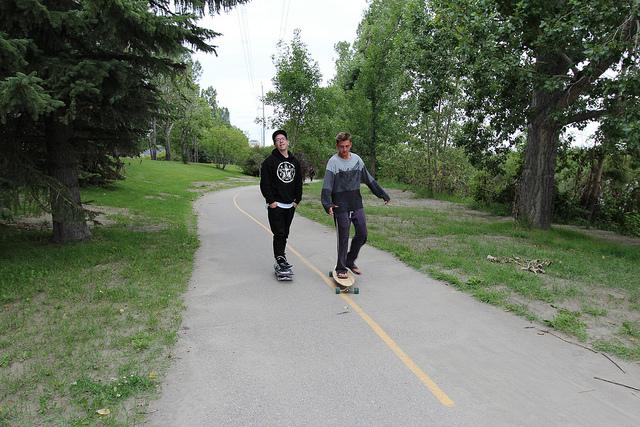How many potholes are visible?
Short answer required. 0. What is the man holding?
Concise answer only. Nothing. What is the pathway made of?
Write a very short answer. Cement. Is it dark out?
Quick response, please. No. Is the path crowded?
Answer briefly. No. Is this street covered in rain water?
Answer briefly. No. How many people are riding skateboards on this street?
Keep it brief. 2. What are the people doing?
Give a very brief answer. Skateboarding. What is he on?
Keep it brief. Skateboard. Are there cars in this picture?
Write a very short answer. No. What is cast?
Quick response, please. Nothing. What is the kids on?
Keep it brief. Skateboard. 